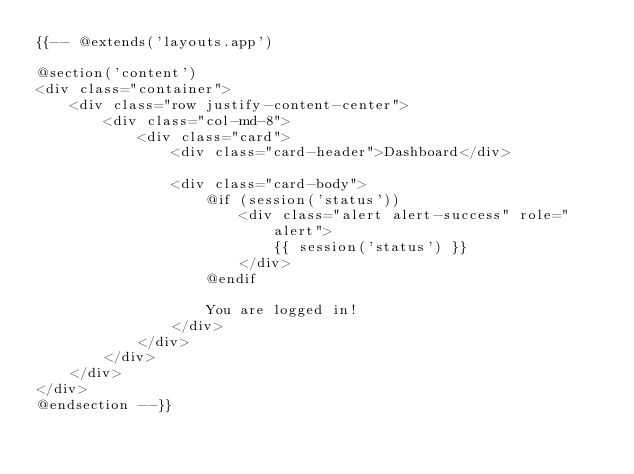Convert code to text. <code><loc_0><loc_0><loc_500><loc_500><_PHP_>{{-- @extends('layouts.app')

@section('content')
<div class="container">
    <div class="row justify-content-center">
        <div class="col-md-8">
            <div class="card">
                <div class="card-header">Dashboard</div>

                <div class="card-body">
                    @if (session('status'))
                        <div class="alert alert-success" role="alert">
                            {{ session('status') }}
                        </div>
                    @endif

                    You are logged in!
                </div>
            </div>
        </div>
    </div>
</div>
@endsection --}}
</code> 